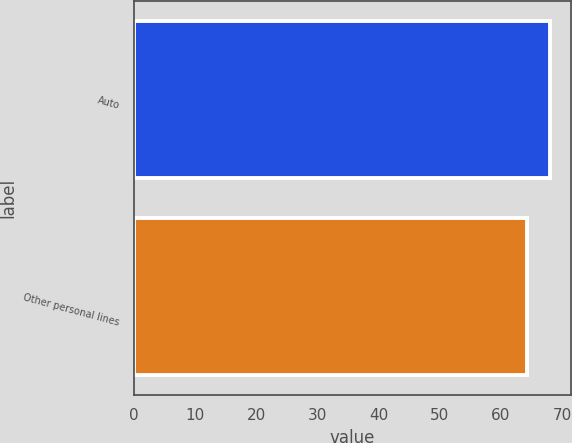<chart> <loc_0><loc_0><loc_500><loc_500><bar_chart><fcel>Auto<fcel>Other personal lines<nl><fcel>68.1<fcel>64.3<nl></chart> 